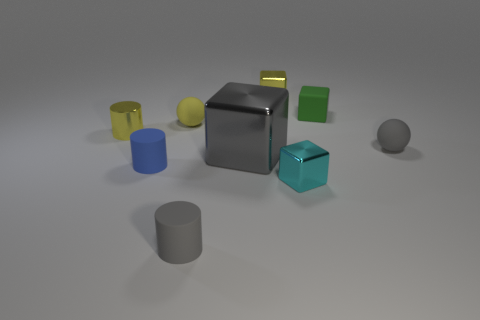Subtract all rubber cylinders. How many cylinders are left? 1 Subtract all yellow blocks. How many blocks are left? 3 Subtract 3 cubes. How many cubes are left? 1 Subtract all spheres. How many objects are left? 7 Subtract all purple blocks. How many purple cylinders are left? 0 Subtract all gray matte spheres. Subtract all small cyan rubber cylinders. How many objects are left? 8 Add 6 small green objects. How many small green objects are left? 7 Add 7 green rubber cubes. How many green rubber cubes exist? 8 Subtract 1 blue cylinders. How many objects are left? 8 Subtract all cyan cubes. Subtract all brown spheres. How many cubes are left? 3 